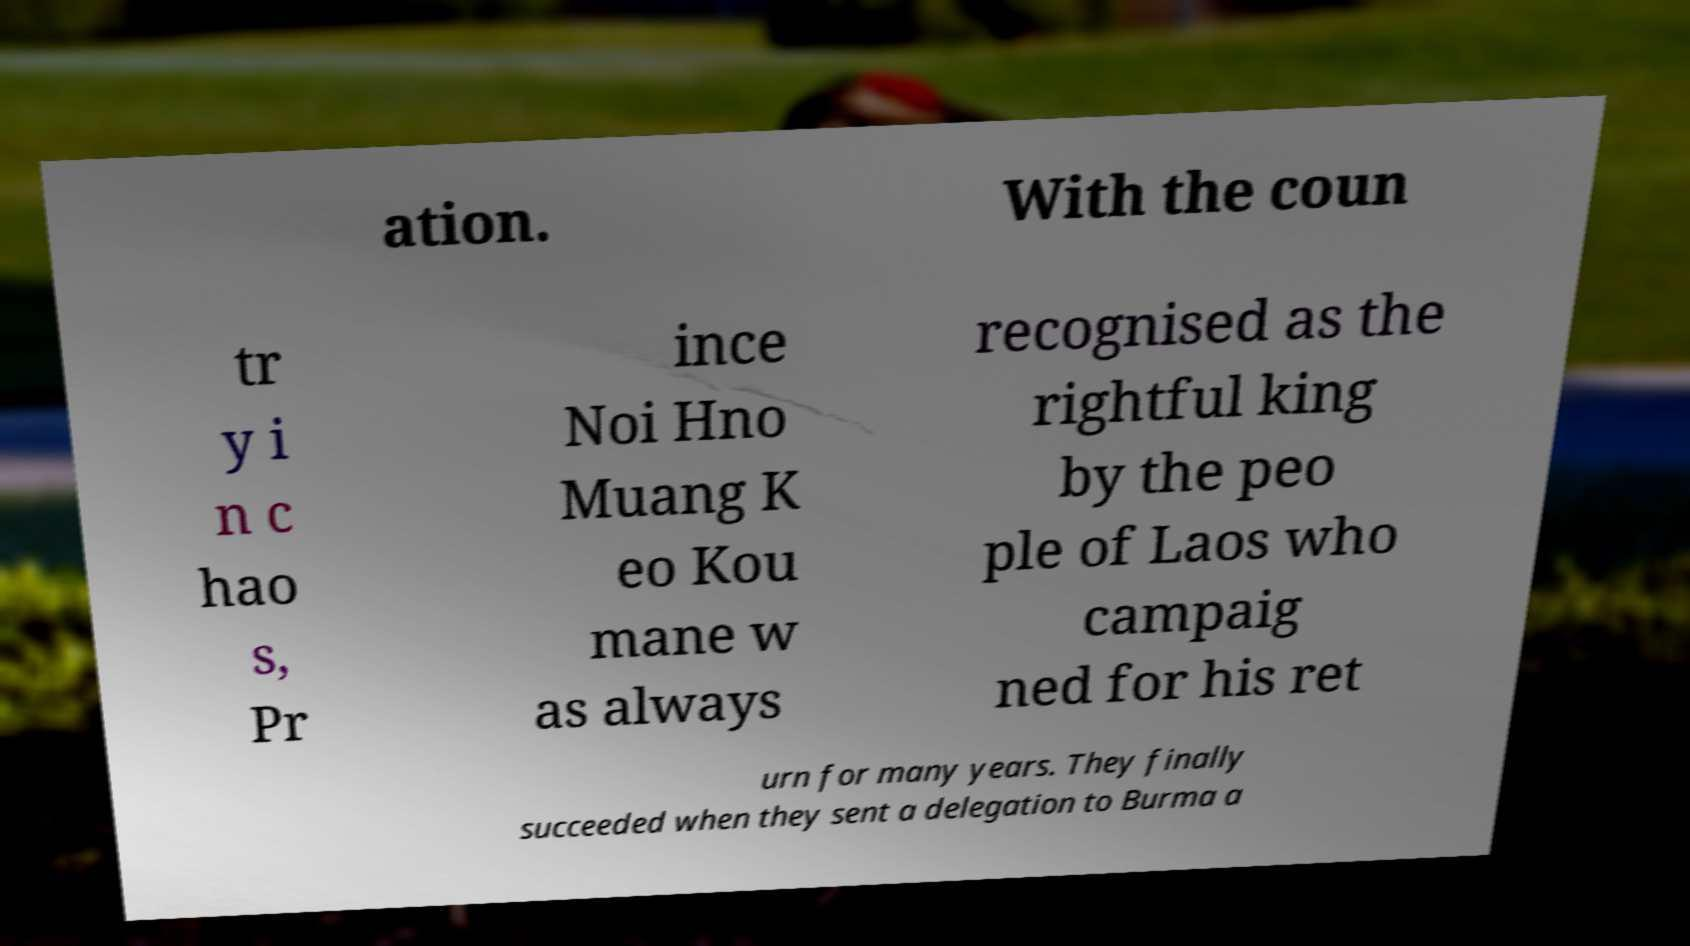What messages or text are displayed in this image? I need them in a readable, typed format. ation. With the coun tr y i n c hao s, Pr ince Noi Hno Muang K eo Kou mane w as always recognised as the rightful king by the peo ple of Laos who campaig ned for his ret urn for many years. They finally succeeded when they sent a delegation to Burma a 